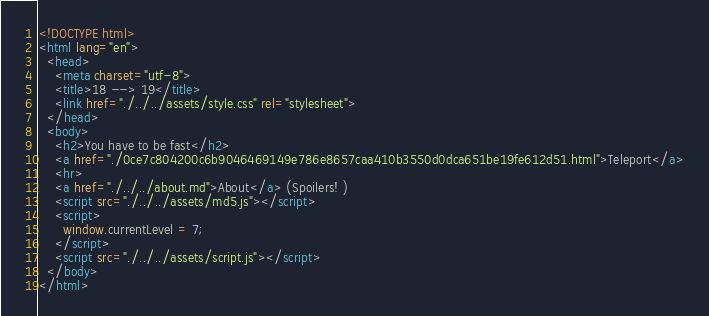Convert code to text. <code><loc_0><loc_0><loc_500><loc_500><_HTML_><!DOCTYPE html>
<html lang="en">
  <head>
    <meta charset="utf-8">
    <title>18 --> 19</title>
    <link href="./../../assets/style.css" rel="stylesheet">
  </head>
  <body>
    <h2>You have to be fast</h2>
    <a href="./0ce7c804200c6b9046469149e786e8657caa410b3550d0dca651be19fe612d51.html">Teleport</a>
    <hr>
    <a href="./../../about.md">About</a> (Spoilers! )
    <script src="./../../assets/md5.js"></script>
    <script>
      window.currentLevel = 7;
    </script>
    <script src="./../../assets/script.js"></script>
  </body>
</html></code> 